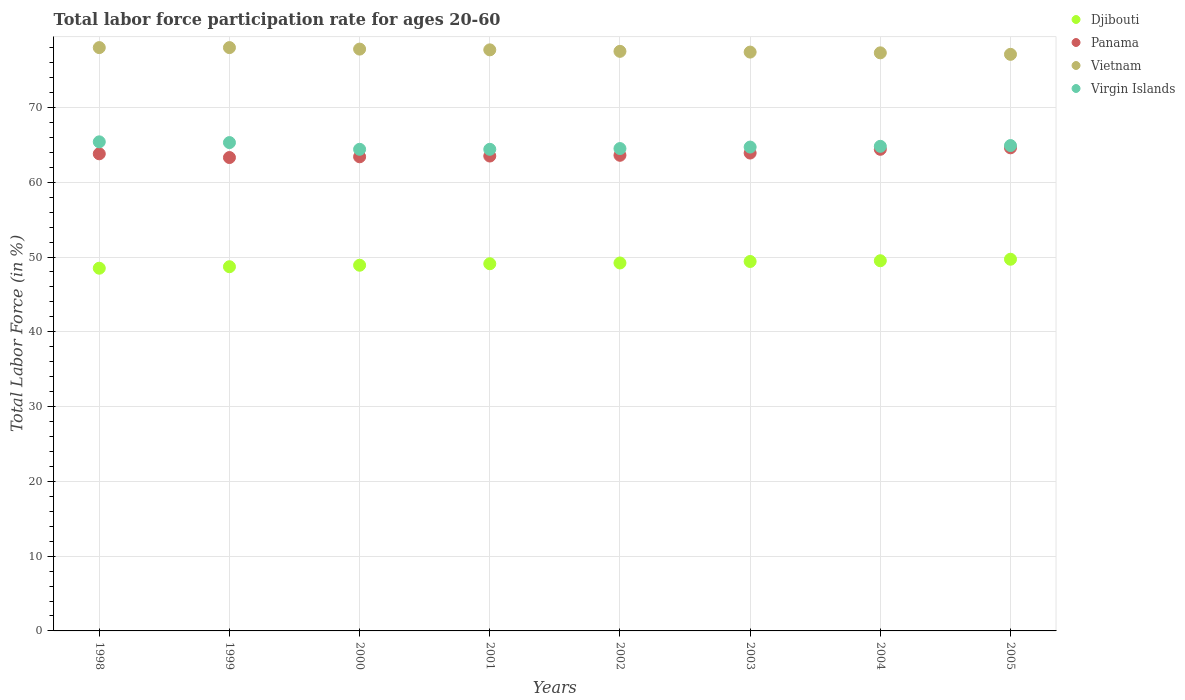Is the number of dotlines equal to the number of legend labels?
Your answer should be compact. Yes. What is the labor force participation rate in Vietnam in 1998?
Keep it short and to the point. 78. Across all years, what is the maximum labor force participation rate in Virgin Islands?
Your answer should be compact. 65.4. Across all years, what is the minimum labor force participation rate in Panama?
Your answer should be compact. 63.3. In which year was the labor force participation rate in Virgin Islands maximum?
Offer a terse response. 1998. In which year was the labor force participation rate in Virgin Islands minimum?
Keep it short and to the point. 2000. What is the total labor force participation rate in Djibouti in the graph?
Ensure brevity in your answer.  393. What is the difference between the labor force participation rate in Panama in 2002 and that in 2005?
Your answer should be compact. -1. What is the difference between the labor force participation rate in Panama in 2002 and the labor force participation rate in Virgin Islands in 2003?
Keep it short and to the point. -1.1. What is the average labor force participation rate in Djibouti per year?
Offer a very short reply. 49.13. In the year 1999, what is the difference between the labor force participation rate in Vietnam and labor force participation rate in Virgin Islands?
Offer a very short reply. 12.7. In how many years, is the labor force participation rate in Virgin Islands greater than 36 %?
Give a very brief answer. 8. What is the ratio of the labor force participation rate in Djibouti in 1998 to that in 2002?
Offer a very short reply. 0.99. Is the labor force participation rate in Virgin Islands in 2001 less than that in 2004?
Keep it short and to the point. Yes. Is the difference between the labor force participation rate in Vietnam in 2001 and 2003 greater than the difference between the labor force participation rate in Virgin Islands in 2001 and 2003?
Keep it short and to the point. Yes. What is the difference between the highest and the second highest labor force participation rate in Panama?
Give a very brief answer. 0.2. What is the difference between the highest and the lowest labor force participation rate in Vietnam?
Your response must be concise. 0.9. In how many years, is the labor force participation rate in Panama greater than the average labor force participation rate in Panama taken over all years?
Ensure brevity in your answer.  3. Is the sum of the labor force participation rate in Virgin Islands in 2001 and 2003 greater than the maximum labor force participation rate in Djibouti across all years?
Make the answer very short. Yes. Is it the case that in every year, the sum of the labor force participation rate in Panama and labor force participation rate in Vietnam  is greater than the sum of labor force participation rate in Virgin Islands and labor force participation rate in Djibouti?
Give a very brief answer. Yes. Does the labor force participation rate in Virgin Islands monotonically increase over the years?
Your response must be concise. No. Does the graph contain any zero values?
Provide a short and direct response. No. Where does the legend appear in the graph?
Your answer should be very brief. Top right. How many legend labels are there?
Provide a succinct answer. 4. What is the title of the graph?
Give a very brief answer. Total labor force participation rate for ages 20-60. What is the label or title of the Y-axis?
Provide a short and direct response. Total Labor Force (in %). What is the Total Labor Force (in %) in Djibouti in 1998?
Ensure brevity in your answer.  48.5. What is the Total Labor Force (in %) in Panama in 1998?
Keep it short and to the point. 63.8. What is the Total Labor Force (in %) in Vietnam in 1998?
Keep it short and to the point. 78. What is the Total Labor Force (in %) in Virgin Islands in 1998?
Provide a succinct answer. 65.4. What is the Total Labor Force (in %) of Djibouti in 1999?
Offer a terse response. 48.7. What is the Total Labor Force (in %) in Panama in 1999?
Keep it short and to the point. 63.3. What is the Total Labor Force (in %) of Vietnam in 1999?
Offer a very short reply. 78. What is the Total Labor Force (in %) in Virgin Islands in 1999?
Your response must be concise. 65.3. What is the Total Labor Force (in %) in Djibouti in 2000?
Keep it short and to the point. 48.9. What is the Total Labor Force (in %) in Panama in 2000?
Make the answer very short. 63.4. What is the Total Labor Force (in %) of Vietnam in 2000?
Provide a succinct answer. 77.8. What is the Total Labor Force (in %) of Virgin Islands in 2000?
Offer a terse response. 64.4. What is the Total Labor Force (in %) in Djibouti in 2001?
Offer a very short reply. 49.1. What is the Total Labor Force (in %) of Panama in 2001?
Offer a terse response. 63.5. What is the Total Labor Force (in %) in Vietnam in 2001?
Your answer should be compact. 77.7. What is the Total Labor Force (in %) in Virgin Islands in 2001?
Offer a terse response. 64.4. What is the Total Labor Force (in %) in Djibouti in 2002?
Ensure brevity in your answer.  49.2. What is the Total Labor Force (in %) in Panama in 2002?
Your response must be concise. 63.6. What is the Total Labor Force (in %) in Vietnam in 2002?
Offer a terse response. 77.5. What is the Total Labor Force (in %) in Virgin Islands in 2002?
Provide a short and direct response. 64.5. What is the Total Labor Force (in %) in Djibouti in 2003?
Provide a succinct answer. 49.4. What is the Total Labor Force (in %) in Panama in 2003?
Your answer should be very brief. 63.9. What is the Total Labor Force (in %) in Vietnam in 2003?
Your answer should be very brief. 77.4. What is the Total Labor Force (in %) of Virgin Islands in 2003?
Your answer should be compact. 64.7. What is the Total Labor Force (in %) of Djibouti in 2004?
Your response must be concise. 49.5. What is the Total Labor Force (in %) of Panama in 2004?
Your answer should be very brief. 64.4. What is the Total Labor Force (in %) in Vietnam in 2004?
Provide a short and direct response. 77.3. What is the Total Labor Force (in %) in Virgin Islands in 2004?
Give a very brief answer. 64.8. What is the Total Labor Force (in %) of Djibouti in 2005?
Offer a very short reply. 49.7. What is the Total Labor Force (in %) in Panama in 2005?
Offer a very short reply. 64.6. What is the Total Labor Force (in %) of Vietnam in 2005?
Make the answer very short. 77.1. What is the Total Labor Force (in %) in Virgin Islands in 2005?
Provide a succinct answer. 64.9. Across all years, what is the maximum Total Labor Force (in %) of Djibouti?
Your answer should be very brief. 49.7. Across all years, what is the maximum Total Labor Force (in %) of Panama?
Offer a very short reply. 64.6. Across all years, what is the maximum Total Labor Force (in %) of Virgin Islands?
Your answer should be compact. 65.4. Across all years, what is the minimum Total Labor Force (in %) in Djibouti?
Your answer should be compact. 48.5. Across all years, what is the minimum Total Labor Force (in %) of Panama?
Your answer should be compact. 63.3. Across all years, what is the minimum Total Labor Force (in %) of Vietnam?
Give a very brief answer. 77.1. Across all years, what is the minimum Total Labor Force (in %) of Virgin Islands?
Your response must be concise. 64.4. What is the total Total Labor Force (in %) in Djibouti in the graph?
Your response must be concise. 393. What is the total Total Labor Force (in %) of Panama in the graph?
Keep it short and to the point. 510.5. What is the total Total Labor Force (in %) in Vietnam in the graph?
Ensure brevity in your answer.  620.8. What is the total Total Labor Force (in %) in Virgin Islands in the graph?
Ensure brevity in your answer.  518.4. What is the difference between the Total Labor Force (in %) of Virgin Islands in 1998 and that in 1999?
Make the answer very short. 0.1. What is the difference between the Total Labor Force (in %) of Panama in 1998 and that in 2000?
Ensure brevity in your answer.  0.4. What is the difference between the Total Labor Force (in %) in Vietnam in 1998 and that in 2000?
Make the answer very short. 0.2. What is the difference between the Total Labor Force (in %) of Virgin Islands in 1998 and that in 2000?
Your response must be concise. 1. What is the difference between the Total Labor Force (in %) in Panama in 1998 and that in 2002?
Offer a very short reply. 0.2. What is the difference between the Total Labor Force (in %) in Vietnam in 1998 and that in 2002?
Offer a terse response. 0.5. What is the difference between the Total Labor Force (in %) in Virgin Islands in 1998 and that in 2002?
Give a very brief answer. 0.9. What is the difference between the Total Labor Force (in %) in Vietnam in 1998 and that in 2003?
Ensure brevity in your answer.  0.6. What is the difference between the Total Labor Force (in %) of Virgin Islands in 1998 and that in 2003?
Offer a terse response. 0.7. What is the difference between the Total Labor Force (in %) of Panama in 1998 and that in 2004?
Your answer should be very brief. -0.6. What is the difference between the Total Labor Force (in %) of Djibouti in 1998 and that in 2005?
Provide a succinct answer. -1.2. What is the difference between the Total Labor Force (in %) in Vietnam in 1998 and that in 2005?
Ensure brevity in your answer.  0.9. What is the difference between the Total Labor Force (in %) of Virgin Islands in 1998 and that in 2005?
Your answer should be compact. 0.5. What is the difference between the Total Labor Force (in %) in Djibouti in 1999 and that in 2000?
Keep it short and to the point. -0.2. What is the difference between the Total Labor Force (in %) in Panama in 1999 and that in 2000?
Your response must be concise. -0.1. What is the difference between the Total Labor Force (in %) in Vietnam in 1999 and that in 2000?
Keep it short and to the point. 0.2. What is the difference between the Total Labor Force (in %) of Djibouti in 1999 and that in 2001?
Provide a succinct answer. -0.4. What is the difference between the Total Labor Force (in %) in Virgin Islands in 1999 and that in 2001?
Your response must be concise. 0.9. What is the difference between the Total Labor Force (in %) in Panama in 1999 and that in 2002?
Keep it short and to the point. -0.3. What is the difference between the Total Labor Force (in %) of Vietnam in 1999 and that in 2002?
Ensure brevity in your answer.  0.5. What is the difference between the Total Labor Force (in %) in Djibouti in 1999 and that in 2003?
Give a very brief answer. -0.7. What is the difference between the Total Labor Force (in %) in Vietnam in 1999 and that in 2004?
Your response must be concise. 0.7. What is the difference between the Total Labor Force (in %) of Virgin Islands in 1999 and that in 2004?
Make the answer very short. 0.5. What is the difference between the Total Labor Force (in %) of Djibouti in 1999 and that in 2005?
Provide a short and direct response. -1. What is the difference between the Total Labor Force (in %) in Panama in 1999 and that in 2005?
Your response must be concise. -1.3. What is the difference between the Total Labor Force (in %) in Panama in 2000 and that in 2001?
Keep it short and to the point. -0.1. What is the difference between the Total Labor Force (in %) of Virgin Islands in 2000 and that in 2001?
Your response must be concise. 0. What is the difference between the Total Labor Force (in %) in Panama in 2000 and that in 2002?
Provide a short and direct response. -0.2. What is the difference between the Total Labor Force (in %) in Djibouti in 2000 and that in 2003?
Provide a short and direct response. -0.5. What is the difference between the Total Labor Force (in %) in Vietnam in 2000 and that in 2003?
Your answer should be very brief. 0.4. What is the difference between the Total Labor Force (in %) in Virgin Islands in 2000 and that in 2003?
Your answer should be very brief. -0.3. What is the difference between the Total Labor Force (in %) in Djibouti in 2000 and that in 2004?
Offer a terse response. -0.6. What is the difference between the Total Labor Force (in %) in Vietnam in 2000 and that in 2004?
Your answer should be very brief. 0.5. What is the difference between the Total Labor Force (in %) in Virgin Islands in 2000 and that in 2004?
Your answer should be very brief. -0.4. What is the difference between the Total Labor Force (in %) of Panama in 2000 and that in 2005?
Your answer should be compact. -1.2. What is the difference between the Total Labor Force (in %) of Vietnam in 2000 and that in 2005?
Give a very brief answer. 0.7. What is the difference between the Total Labor Force (in %) in Virgin Islands in 2000 and that in 2005?
Offer a very short reply. -0.5. What is the difference between the Total Labor Force (in %) in Panama in 2001 and that in 2002?
Make the answer very short. -0.1. What is the difference between the Total Labor Force (in %) of Panama in 2001 and that in 2003?
Keep it short and to the point. -0.4. What is the difference between the Total Labor Force (in %) of Virgin Islands in 2001 and that in 2003?
Provide a succinct answer. -0.3. What is the difference between the Total Labor Force (in %) in Djibouti in 2001 and that in 2004?
Provide a succinct answer. -0.4. What is the difference between the Total Labor Force (in %) in Panama in 2001 and that in 2004?
Keep it short and to the point. -0.9. What is the difference between the Total Labor Force (in %) of Virgin Islands in 2001 and that in 2004?
Your response must be concise. -0.4. What is the difference between the Total Labor Force (in %) in Vietnam in 2001 and that in 2005?
Your answer should be very brief. 0.6. What is the difference between the Total Labor Force (in %) of Virgin Islands in 2001 and that in 2005?
Give a very brief answer. -0.5. What is the difference between the Total Labor Force (in %) in Djibouti in 2002 and that in 2003?
Make the answer very short. -0.2. What is the difference between the Total Labor Force (in %) of Panama in 2002 and that in 2003?
Your answer should be compact. -0.3. What is the difference between the Total Labor Force (in %) in Panama in 2002 and that in 2004?
Your response must be concise. -0.8. What is the difference between the Total Labor Force (in %) of Vietnam in 2002 and that in 2004?
Your answer should be very brief. 0.2. What is the difference between the Total Labor Force (in %) of Panama in 2002 and that in 2005?
Provide a succinct answer. -1. What is the difference between the Total Labor Force (in %) of Vietnam in 2002 and that in 2005?
Ensure brevity in your answer.  0.4. What is the difference between the Total Labor Force (in %) of Djibouti in 2003 and that in 2004?
Your response must be concise. -0.1. What is the difference between the Total Labor Force (in %) in Panama in 2003 and that in 2004?
Your answer should be very brief. -0.5. What is the difference between the Total Labor Force (in %) of Virgin Islands in 2003 and that in 2004?
Your answer should be very brief. -0.1. What is the difference between the Total Labor Force (in %) in Djibouti in 2003 and that in 2005?
Offer a very short reply. -0.3. What is the difference between the Total Labor Force (in %) of Djibouti in 2004 and that in 2005?
Provide a succinct answer. -0.2. What is the difference between the Total Labor Force (in %) in Panama in 2004 and that in 2005?
Offer a very short reply. -0.2. What is the difference between the Total Labor Force (in %) in Virgin Islands in 2004 and that in 2005?
Provide a short and direct response. -0.1. What is the difference between the Total Labor Force (in %) in Djibouti in 1998 and the Total Labor Force (in %) in Panama in 1999?
Your response must be concise. -14.8. What is the difference between the Total Labor Force (in %) in Djibouti in 1998 and the Total Labor Force (in %) in Vietnam in 1999?
Ensure brevity in your answer.  -29.5. What is the difference between the Total Labor Force (in %) in Djibouti in 1998 and the Total Labor Force (in %) in Virgin Islands in 1999?
Offer a terse response. -16.8. What is the difference between the Total Labor Force (in %) of Panama in 1998 and the Total Labor Force (in %) of Vietnam in 1999?
Your answer should be compact. -14.2. What is the difference between the Total Labor Force (in %) in Vietnam in 1998 and the Total Labor Force (in %) in Virgin Islands in 1999?
Make the answer very short. 12.7. What is the difference between the Total Labor Force (in %) in Djibouti in 1998 and the Total Labor Force (in %) in Panama in 2000?
Provide a succinct answer. -14.9. What is the difference between the Total Labor Force (in %) in Djibouti in 1998 and the Total Labor Force (in %) in Vietnam in 2000?
Provide a succinct answer. -29.3. What is the difference between the Total Labor Force (in %) of Djibouti in 1998 and the Total Labor Force (in %) of Virgin Islands in 2000?
Give a very brief answer. -15.9. What is the difference between the Total Labor Force (in %) in Panama in 1998 and the Total Labor Force (in %) in Vietnam in 2000?
Give a very brief answer. -14. What is the difference between the Total Labor Force (in %) in Djibouti in 1998 and the Total Labor Force (in %) in Vietnam in 2001?
Provide a short and direct response. -29.2. What is the difference between the Total Labor Force (in %) of Djibouti in 1998 and the Total Labor Force (in %) of Virgin Islands in 2001?
Your answer should be very brief. -15.9. What is the difference between the Total Labor Force (in %) in Panama in 1998 and the Total Labor Force (in %) in Virgin Islands in 2001?
Give a very brief answer. -0.6. What is the difference between the Total Labor Force (in %) of Djibouti in 1998 and the Total Labor Force (in %) of Panama in 2002?
Ensure brevity in your answer.  -15.1. What is the difference between the Total Labor Force (in %) in Djibouti in 1998 and the Total Labor Force (in %) in Vietnam in 2002?
Ensure brevity in your answer.  -29. What is the difference between the Total Labor Force (in %) of Panama in 1998 and the Total Labor Force (in %) of Vietnam in 2002?
Make the answer very short. -13.7. What is the difference between the Total Labor Force (in %) of Vietnam in 1998 and the Total Labor Force (in %) of Virgin Islands in 2002?
Your answer should be very brief. 13.5. What is the difference between the Total Labor Force (in %) in Djibouti in 1998 and the Total Labor Force (in %) in Panama in 2003?
Your response must be concise. -15.4. What is the difference between the Total Labor Force (in %) of Djibouti in 1998 and the Total Labor Force (in %) of Vietnam in 2003?
Give a very brief answer. -28.9. What is the difference between the Total Labor Force (in %) of Djibouti in 1998 and the Total Labor Force (in %) of Virgin Islands in 2003?
Provide a short and direct response. -16.2. What is the difference between the Total Labor Force (in %) in Panama in 1998 and the Total Labor Force (in %) in Vietnam in 2003?
Your answer should be very brief. -13.6. What is the difference between the Total Labor Force (in %) in Panama in 1998 and the Total Labor Force (in %) in Virgin Islands in 2003?
Ensure brevity in your answer.  -0.9. What is the difference between the Total Labor Force (in %) of Vietnam in 1998 and the Total Labor Force (in %) of Virgin Islands in 2003?
Make the answer very short. 13.3. What is the difference between the Total Labor Force (in %) of Djibouti in 1998 and the Total Labor Force (in %) of Panama in 2004?
Ensure brevity in your answer.  -15.9. What is the difference between the Total Labor Force (in %) in Djibouti in 1998 and the Total Labor Force (in %) in Vietnam in 2004?
Provide a succinct answer. -28.8. What is the difference between the Total Labor Force (in %) of Djibouti in 1998 and the Total Labor Force (in %) of Virgin Islands in 2004?
Offer a very short reply. -16.3. What is the difference between the Total Labor Force (in %) of Panama in 1998 and the Total Labor Force (in %) of Vietnam in 2004?
Ensure brevity in your answer.  -13.5. What is the difference between the Total Labor Force (in %) of Djibouti in 1998 and the Total Labor Force (in %) of Panama in 2005?
Give a very brief answer. -16.1. What is the difference between the Total Labor Force (in %) of Djibouti in 1998 and the Total Labor Force (in %) of Vietnam in 2005?
Give a very brief answer. -28.6. What is the difference between the Total Labor Force (in %) in Djibouti in 1998 and the Total Labor Force (in %) in Virgin Islands in 2005?
Your answer should be very brief. -16.4. What is the difference between the Total Labor Force (in %) in Panama in 1998 and the Total Labor Force (in %) in Vietnam in 2005?
Provide a succinct answer. -13.3. What is the difference between the Total Labor Force (in %) in Vietnam in 1998 and the Total Labor Force (in %) in Virgin Islands in 2005?
Keep it short and to the point. 13.1. What is the difference between the Total Labor Force (in %) of Djibouti in 1999 and the Total Labor Force (in %) of Panama in 2000?
Your answer should be very brief. -14.7. What is the difference between the Total Labor Force (in %) in Djibouti in 1999 and the Total Labor Force (in %) in Vietnam in 2000?
Your answer should be compact. -29.1. What is the difference between the Total Labor Force (in %) of Djibouti in 1999 and the Total Labor Force (in %) of Virgin Islands in 2000?
Offer a very short reply. -15.7. What is the difference between the Total Labor Force (in %) in Panama in 1999 and the Total Labor Force (in %) in Vietnam in 2000?
Give a very brief answer. -14.5. What is the difference between the Total Labor Force (in %) of Vietnam in 1999 and the Total Labor Force (in %) of Virgin Islands in 2000?
Keep it short and to the point. 13.6. What is the difference between the Total Labor Force (in %) of Djibouti in 1999 and the Total Labor Force (in %) of Panama in 2001?
Your response must be concise. -14.8. What is the difference between the Total Labor Force (in %) of Djibouti in 1999 and the Total Labor Force (in %) of Vietnam in 2001?
Provide a succinct answer. -29. What is the difference between the Total Labor Force (in %) in Djibouti in 1999 and the Total Labor Force (in %) in Virgin Islands in 2001?
Provide a succinct answer. -15.7. What is the difference between the Total Labor Force (in %) in Panama in 1999 and the Total Labor Force (in %) in Vietnam in 2001?
Your answer should be compact. -14.4. What is the difference between the Total Labor Force (in %) in Panama in 1999 and the Total Labor Force (in %) in Virgin Islands in 2001?
Offer a terse response. -1.1. What is the difference between the Total Labor Force (in %) of Vietnam in 1999 and the Total Labor Force (in %) of Virgin Islands in 2001?
Provide a short and direct response. 13.6. What is the difference between the Total Labor Force (in %) of Djibouti in 1999 and the Total Labor Force (in %) of Panama in 2002?
Your answer should be very brief. -14.9. What is the difference between the Total Labor Force (in %) in Djibouti in 1999 and the Total Labor Force (in %) in Vietnam in 2002?
Offer a terse response. -28.8. What is the difference between the Total Labor Force (in %) in Djibouti in 1999 and the Total Labor Force (in %) in Virgin Islands in 2002?
Give a very brief answer. -15.8. What is the difference between the Total Labor Force (in %) in Panama in 1999 and the Total Labor Force (in %) in Virgin Islands in 2002?
Ensure brevity in your answer.  -1.2. What is the difference between the Total Labor Force (in %) in Djibouti in 1999 and the Total Labor Force (in %) in Panama in 2003?
Make the answer very short. -15.2. What is the difference between the Total Labor Force (in %) in Djibouti in 1999 and the Total Labor Force (in %) in Vietnam in 2003?
Offer a terse response. -28.7. What is the difference between the Total Labor Force (in %) of Panama in 1999 and the Total Labor Force (in %) of Vietnam in 2003?
Provide a succinct answer. -14.1. What is the difference between the Total Labor Force (in %) of Panama in 1999 and the Total Labor Force (in %) of Virgin Islands in 2003?
Your answer should be compact. -1.4. What is the difference between the Total Labor Force (in %) of Djibouti in 1999 and the Total Labor Force (in %) of Panama in 2004?
Provide a short and direct response. -15.7. What is the difference between the Total Labor Force (in %) of Djibouti in 1999 and the Total Labor Force (in %) of Vietnam in 2004?
Provide a succinct answer. -28.6. What is the difference between the Total Labor Force (in %) in Djibouti in 1999 and the Total Labor Force (in %) in Virgin Islands in 2004?
Keep it short and to the point. -16.1. What is the difference between the Total Labor Force (in %) in Djibouti in 1999 and the Total Labor Force (in %) in Panama in 2005?
Offer a very short reply. -15.9. What is the difference between the Total Labor Force (in %) of Djibouti in 1999 and the Total Labor Force (in %) of Vietnam in 2005?
Ensure brevity in your answer.  -28.4. What is the difference between the Total Labor Force (in %) of Djibouti in 1999 and the Total Labor Force (in %) of Virgin Islands in 2005?
Keep it short and to the point. -16.2. What is the difference between the Total Labor Force (in %) in Panama in 1999 and the Total Labor Force (in %) in Vietnam in 2005?
Give a very brief answer. -13.8. What is the difference between the Total Labor Force (in %) of Djibouti in 2000 and the Total Labor Force (in %) of Panama in 2001?
Make the answer very short. -14.6. What is the difference between the Total Labor Force (in %) in Djibouti in 2000 and the Total Labor Force (in %) in Vietnam in 2001?
Provide a succinct answer. -28.8. What is the difference between the Total Labor Force (in %) in Djibouti in 2000 and the Total Labor Force (in %) in Virgin Islands in 2001?
Offer a very short reply. -15.5. What is the difference between the Total Labor Force (in %) of Panama in 2000 and the Total Labor Force (in %) of Vietnam in 2001?
Provide a short and direct response. -14.3. What is the difference between the Total Labor Force (in %) of Vietnam in 2000 and the Total Labor Force (in %) of Virgin Islands in 2001?
Keep it short and to the point. 13.4. What is the difference between the Total Labor Force (in %) in Djibouti in 2000 and the Total Labor Force (in %) in Panama in 2002?
Ensure brevity in your answer.  -14.7. What is the difference between the Total Labor Force (in %) of Djibouti in 2000 and the Total Labor Force (in %) of Vietnam in 2002?
Your answer should be compact. -28.6. What is the difference between the Total Labor Force (in %) of Djibouti in 2000 and the Total Labor Force (in %) of Virgin Islands in 2002?
Your answer should be very brief. -15.6. What is the difference between the Total Labor Force (in %) of Panama in 2000 and the Total Labor Force (in %) of Vietnam in 2002?
Ensure brevity in your answer.  -14.1. What is the difference between the Total Labor Force (in %) in Panama in 2000 and the Total Labor Force (in %) in Virgin Islands in 2002?
Your answer should be compact. -1.1. What is the difference between the Total Labor Force (in %) of Vietnam in 2000 and the Total Labor Force (in %) of Virgin Islands in 2002?
Make the answer very short. 13.3. What is the difference between the Total Labor Force (in %) in Djibouti in 2000 and the Total Labor Force (in %) in Panama in 2003?
Keep it short and to the point. -15. What is the difference between the Total Labor Force (in %) of Djibouti in 2000 and the Total Labor Force (in %) of Vietnam in 2003?
Offer a terse response. -28.5. What is the difference between the Total Labor Force (in %) of Djibouti in 2000 and the Total Labor Force (in %) of Virgin Islands in 2003?
Provide a succinct answer. -15.8. What is the difference between the Total Labor Force (in %) of Panama in 2000 and the Total Labor Force (in %) of Vietnam in 2003?
Your answer should be very brief. -14. What is the difference between the Total Labor Force (in %) of Vietnam in 2000 and the Total Labor Force (in %) of Virgin Islands in 2003?
Ensure brevity in your answer.  13.1. What is the difference between the Total Labor Force (in %) of Djibouti in 2000 and the Total Labor Force (in %) of Panama in 2004?
Your answer should be very brief. -15.5. What is the difference between the Total Labor Force (in %) in Djibouti in 2000 and the Total Labor Force (in %) in Vietnam in 2004?
Your response must be concise. -28.4. What is the difference between the Total Labor Force (in %) of Djibouti in 2000 and the Total Labor Force (in %) of Virgin Islands in 2004?
Give a very brief answer. -15.9. What is the difference between the Total Labor Force (in %) of Panama in 2000 and the Total Labor Force (in %) of Virgin Islands in 2004?
Offer a terse response. -1.4. What is the difference between the Total Labor Force (in %) of Djibouti in 2000 and the Total Labor Force (in %) of Panama in 2005?
Provide a short and direct response. -15.7. What is the difference between the Total Labor Force (in %) of Djibouti in 2000 and the Total Labor Force (in %) of Vietnam in 2005?
Offer a terse response. -28.2. What is the difference between the Total Labor Force (in %) in Panama in 2000 and the Total Labor Force (in %) in Vietnam in 2005?
Provide a short and direct response. -13.7. What is the difference between the Total Labor Force (in %) of Djibouti in 2001 and the Total Labor Force (in %) of Vietnam in 2002?
Give a very brief answer. -28.4. What is the difference between the Total Labor Force (in %) in Djibouti in 2001 and the Total Labor Force (in %) in Virgin Islands in 2002?
Provide a succinct answer. -15.4. What is the difference between the Total Labor Force (in %) of Panama in 2001 and the Total Labor Force (in %) of Vietnam in 2002?
Provide a short and direct response. -14. What is the difference between the Total Labor Force (in %) of Vietnam in 2001 and the Total Labor Force (in %) of Virgin Islands in 2002?
Your answer should be compact. 13.2. What is the difference between the Total Labor Force (in %) in Djibouti in 2001 and the Total Labor Force (in %) in Panama in 2003?
Provide a short and direct response. -14.8. What is the difference between the Total Labor Force (in %) of Djibouti in 2001 and the Total Labor Force (in %) of Vietnam in 2003?
Keep it short and to the point. -28.3. What is the difference between the Total Labor Force (in %) of Djibouti in 2001 and the Total Labor Force (in %) of Virgin Islands in 2003?
Your answer should be very brief. -15.6. What is the difference between the Total Labor Force (in %) in Djibouti in 2001 and the Total Labor Force (in %) in Panama in 2004?
Make the answer very short. -15.3. What is the difference between the Total Labor Force (in %) of Djibouti in 2001 and the Total Labor Force (in %) of Vietnam in 2004?
Your answer should be compact. -28.2. What is the difference between the Total Labor Force (in %) in Djibouti in 2001 and the Total Labor Force (in %) in Virgin Islands in 2004?
Provide a succinct answer. -15.7. What is the difference between the Total Labor Force (in %) of Vietnam in 2001 and the Total Labor Force (in %) of Virgin Islands in 2004?
Offer a terse response. 12.9. What is the difference between the Total Labor Force (in %) in Djibouti in 2001 and the Total Labor Force (in %) in Panama in 2005?
Provide a succinct answer. -15.5. What is the difference between the Total Labor Force (in %) in Djibouti in 2001 and the Total Labor Force (in %) in Vietnam in 2005?
Provide a short and direct response. -28. What is the difference between the Total Labor Force (in %) of Djibouti in 2001 and the Total Labor Force (in %) of Virgin Islands in 2005?
Your answer should be compact. -15.8. What is the difference between the Total Labor Force (in %) in Panama in 2001 and the Total Labor Force (in %) in Virgin Islands in 2005?
Keep it short and to the point. -1.4. What is the difference between the Total Labor Force (in %) of Djibouti in 2002 and the Total Labor Force (in %) of Panama in 2003?
Offer a very short reply. -14.7. What is the difference between the Total Labor Force (in %) of Djibouti in 2002 and the Total Labor Force (in %) of Vietnam in 2003?
Your response must be concise. -28.2. What is the difference between the Total Labor Force (in %) in Djibouti in 2002 and the Total Labor Force (in %) in Virgin Islands in 2003?
Your answer should be very brief. -15.5. What is the difference between the Total Labor Force (in %) of Panama in 2002 and the Total Labor Force (in %) of Virgin Islands in 2003?
Offer a terse response. -1.1. What is the difference between the Total Labor Force (in %) in Djibouti in 2002 and the Total Labor Force (in %) in Panama in 2004?
Keep it short and to the point. -15.2. What is the difference between the Total Labor Force (in %) in Djibouti in 2002 and the Total Labor Force (in %) in Vietnam in 2004?
Keep it short and to the point. -28.1. What is the difference between the Total Labor Force (in %) in Djibouti in 2002 and the Total Labor Force (in %) in Virgin Islands in 2004?
Keep it short and to the point. -15.6. What is the difference between the Total Labor Force (in %) of Panama in 2002 and the Total Labor Force (in %) of Vietnam in 2004?
Keep it short and to the point. -13.7. What is the difference between the Total Labor Force (in %) of Panama in 2002 and the Total Labor Force (in %) of Virgin Islands in 2004?
Your answer should be compact. -1.2. What is the difference between the Total Labor Force (in %) in Djibouti in 2002 and the Total Labor Force (in %) in Panama in 2005?
Make the answer very short. -15.4. What is the difference between the Total Labor Force (in %) of Djibouti in 2002 and the Total Labor Force (in %) of Vietnam in 2005?
Your response must be concise. -27.9. What is the difference between the Total Labor Force (in %) of Djibouti in 2002 and the Total Labor Force (in %) of Virgin Islands in 2005?
Your answer should be very brief. -15.7. What is the difference between the Total Labor Force (in %) in Panama in 2002 and the Total Labor Force (in %) in Vietnam in 2005?
Offer a very short reply. -13.5. What is the difference between the Total Labor Force (in %) in Panama in 2002 and the Total Labor Force (in %) in Virgin Islands in 2005?
Provide a short and direct response. -1.3. What is the difference between the Total Labor Force (in %) in Vietnam in 2002 and the Total Labor Force (in %) in Virgin Islands in 2005?
Offer a very short reply. 12.6. What is the difference between the Total Labor Force (in %) of Djibouti in 2003 and the Total Labor Force (in %) of Vietnam in 2004?
Keep it short and to the point. -27.9. What is the difference between the Total Labor Force (in %) in Djibouti in 2003 and the Total Labor Force (in %) in Virgin Islands in 2004?
Your answer should be compact. -15.4. What is the difference between the Total Labor Force (in %) of Panama in 2003 and the Total Labor Force (in %) of Virgin Islands in 2004?
Offer a very short reply. -0.9. What is the difference between the Total Labor Force (in %) of Vietnam in 2003 and the Total Labor Force (in %) of Virgin Islands in 2004?
Offer a very short reply. 12.6. What is the difference between the Total Labor Force (in %) of Djibouti in 2003 and the Total Labor Force (in %) of Panama in 2005?
Give a very brief answer. -15.2. What is the difference between the Total Labor Force (in %) of Djibouti in 2003 and the Total Labor Force (in %) of Vietnam in 2005?
Keep it short and to the point. -27.7. What is the difference between the Total Labor Force (in %) in Djibouti in 2003 and the Total Labor Force (in %) in Virgin Islands in 2005?
Your answer should be compact. -15.5. What is the difference between the Total Labor Force (in %) of Panama in 2003 and the Total Labor Force (in %) of Vietnam in 2005?
Your response must be concise. -13.2. What is the difference between the Total Labor Force (in %) of Panama in 2003 and the Total Labor Force (in %) of Virgin Islands in 2005?
Keep it short and to the point. -1. What is the difference between the Total Labor Force (in %) of Vietnam in 2003 and the Total Labor Force (in %) of Virgin Islands in 2005?
Make the answer very short. 12.5. What is the difference between the Total Labor Force (in %) of Djibouti in 2004 and the Total Labor Force (in %) of Panama in 2005?
Ensure brevity in your answer.  -15.1. What is the difference between the Total Labor Force (in %) of Djibouti in 2004 and the Total Labor Force (in %) of Vietnam in 2005?
Ensure brevity in your answer.  -27.6. What is the difference between the Total Labor Force (in %) of Djibouti in 2004 and the Total Labor Force (in %) of Virgin Islands in 2005?
Give a very brief answer. -15.4. What is the difference between the Total Labor Force (in %) in Panama in 2004 and the Total Labor Force (in %) in Vietnam in 2005?
Offer a very short reply. -12.7. What is the average Total Labor Force (in %) in Djibouti per year?
Keep it short and to the point. 49.12. What is the average Total Labor Force (in %) in Panama per year?
Your answer should be compact. 63.81. What is the average Total Labor Force (in %) of Vietnam per year?
Offer a very short reply. 77.6. What is the average Total Labor Force (in %) of Virgin Islands per year?
Keep it short and to the point. 64.8. In the year 1998, what is the difference between the Total Labor Force (in %) in Djibouti and Total Labor Force (in %) in Panama?
Offer a very short reply. -15.3. In the year 1998, what is the difference between the Total Labor Force (in %) of Djibouti and Total Labor Force (in %) of Vietnam?
Provide a short and direct response. -29.5. In the year 1998, what is the difference between the Total Labor Force (in %) of Djibouti and Total Labor Force (in %) of Virgin Islands?
Provide a short and direct response. -16.9. In the year 1999, what is the difference between the Total Labor Force (in %) of Djibouti and Total Labor Force (in %) of Panama?
Make the answer very short. -14.6. In the year 1999, what is the difference between the Total Labor Force (in %) in Djibouti and Total Labor Force (in %) in Vietnam?
Provide a short and direct response. -29.3. In the year 1999, what is the difference between the Total Labor Force (in %) in Djibouti and Total Labor Force (in %) in Virgin Islands?
Provide a short and direct response. -16.6. In the year 1999, what is the difference between the Total Labor Force (in %) in Panama and Total Labor Force (in %) in Vietnam?
Provide a short and direct response. -14.7. In the year 2000, what is the difference between the Total Labor Force (in %) of Djibouti and Total Labor Force (in %) of Vietnam?
Your answer should be very brief. -28.9. In the year 2000, what is the difference between the Total Labor Force (in %) in Djibouti and Total Labor Force (in %) in Virgin Islands?
Give a very brief answer. -15.5. In the year 2000, what is the difference between the Total Labor Force (in %) of Panama and Total Labor Force (in %) of Vietnam?
Offer a terse response. -14.4. In the year 2000, what is the difference between the Total Labor Force (in %) in Panama and Total Labor Force (in %) in Virgin Islands?
Your answer should be compact. -1. In the year 2001, what is the difference between the Total Labor Force (in %) in Djibouti and Total Labor Force (in %) in Panama?
Offer a very short reply. -14.4. In the year 2001, what is the difference between the Total Labor Force (in %) of Djibouti and Total Labor Force (in %) of Vietnam?
Your answer should be very brief. -28.6. In the year 2001, what is the difference between the Total Labor Force (in %) of Djibouti and Total Labor Force (in %) of Virgin Islands?
Keep it short and to the point. -15.3. In the year 2002, what is the difference between the Total Labor Force (in %) in Djibouti and Total Labor Force (in %) in Panama?
Provide a short and direct response. -14.4. In the year 2002, what is the difference between the Total Labor Force (in %) in Djibouti and Total Labor Force (in %) in Vietnam?
Offer a terse response. -28.3. In the year 2002, what is the difference between the Total Labor Force (in %) in Djibouti and Total Labor Force (in %) in Virgin Islands?
Offer a very short reply. -15.3. In the year 2002, what is the difference between the Total Labor Force (in %) in Vietnam and Total Labor Force (in %) in Virgin Islands?
Provide a succinct answer. 13. In the year 2003, what is the difference between the Total Labor Force (in %) of Djibouti and Total Labor Force (in %) of Vietnam?
Ensure brevity in your answer.  -28. In the year 2003, what is the difference between the Total Labor Force (in %) of Djibouti and Total Labor Force (in %) of Virgin Islands?
Provide a succinct answer. -15.3. In the year 2003, what is the difference between the Total Labor Force (in %) of Panama and Total Labor Force (in %) of Vietnam?
Ensure brevity in your answer.  -13.5. In the year 2003, what is the difference between the Total Labor Force (in %) of Vietnam and Total Labor Force (in %) of Virgin Islands?
Ensure brevity in your answer.  12.7. In the year 2004, what is the difference between the Total Labor Force (in %) in Djibouti and Total Labor Force (in %) in Panama?
Keep it short and to the point. -14.9. In the year 2004, what is the difference between the Total Labor Force (in %) of Djibouti and Total Labor Force (in %) of Vietnam?
Give a very brief answer. -27.8. In the year 2004, what is the difference between the Total Labor Force (in %) in Djibouti and Total Labor Force (in %) in Virgin Islands?
Give a very brief answer. -15.3. In the year 2004, what is the difference between the Total Labor Force (in %) of Panama and Total Labor Force (in %) of Vietnam?
Make the answer very short. -12.9. In the year 2004, what is the difference between the Total Labor Force (in %) of Panama and Total Labor Force (in %) of Virgin Islands?
Your answer should be very brief. -0.4. In the year 2005, what is the difference between the Total Labor Force (in %) in Djibouti and Total Labor Force (in %) in Panama?
Your answer should be very brief. -14.9. In the year 2005, what is the difference between the Total Labor Force (in %) of Djibouti and Total Labor Force (in %) of Vietnam?
Your answer should be very brief. -27.4. In the year 2005, what is the difference between the Total Labor Force (in %) in Djibouti and Total Labor Force (in %) in Virgin Islands?
Provide a succinct answer. -15.2. In the year 2005, what is the difference between the Total Labor Force (in %) in Vietnam and Total Labor Force (in %) in Virgin Islands?
Your answer should be very brief. 12.2. What is the ratio of the Total Labor Force (in %) in Djibouti in 1998 to that in 1999?
Make the answer very short. 1. What is the ratio of the Total Labor Force (in %) in Panama in 1998 to that in 1999?
Make the answer very short. 1.01. What is the ratio of the Total Labor Force (in %) in Vietnam in 1998 to that in 1999?
Provide a succinct answer. 1. What is the ratio of the Total Labor Force (in %) in Vietnam in 1998 to that in 2000?
Provide a succinct answer. 1. What is the ratio of the Total Labor Force (in %) in Virgin Islands in 1998 to that in 2000?
Offer a terse response. 1.02. What is the ratio of the Total Labor Force (in %) in Virgin Islands in 1998 to that in 2001?
Make the answer very short. 1.02. What is the ratio of the Total Labor Force (in %) in Djibouti in 1998 to that in 2002?
Give a very brief answer. 0.99. What is the ratio of the Total Labor Force (in %) of Vietnam in 1998 to that in 2002?
Make the answer very short. 1.01. What is the ratio of the Total Labor Force (in %) in Djibouti in 1998 to that in 2003?
Provide a succinct answer. 0.98. What is the ratio of the Total Labor Force (in %) of Vietnam in 1998 to that in 2003?
Give a very brief answer. 1.01. What is the ratio of the Total Labor Force (in %) of Virgin Islands in 1998 to that in 2003?
Give a very brief answer. 1.01. What is the ratio of the Total Labor Force (in %) in Djibouti in 1998 to that in 2004?
Provide a succinct answer. 0.98. What is the ratio of the Total Labor Force (in %) in Vietnam in 1998 to that in 2004?
Keep it short and to the point. 1.01. What is the ratio of the Total Labor Force (in %) of Virgin Islands in 1998 to that in 2004?
Keep it short and to the point. 1.01. What is the ratio of the Total Labor Force (in %) of Djibouti in 1998 to that in 2005?
Ensure brevity in your answer.  0.98. What is the ratio of the Total Labor Force (in %) of Panama in 1998 to that in 2005?
Keep it short and to the point. 0.99. What is the ratio of the Total Labor Force (in %) of Vietnam in 1998 to that in 2005?
Give a very brief answer. 1.01. What is the ratio of the Total Labor Force (in %) of Virgin Islands in 1998 to that in 2005?
Your answer should be compact. 1.01. What is the ratio of the Total Labor Force (in %) in Djibouti in 1999 to that in 2000?
Provide a short and direct response. 1. What is the ratio of the Total Labor Force (in %) in Panama in 1999 to that in 2000?
Provide a succinct answer. 1. What is the ratio of the Total Labor Force (in %) in Vietnam in 1999 to that in 2000?
Offer a terse response. 1. What is the ratio of the Total Labor Force (in %) of Panama in 1999 to that in 2001?
Your response must be concise. 1. What is the ratio of the Total Labor Force (in %) of Vietnam in 1999 to that in 2001?
Make the answer very short. 1. What is the ratio of the Total Labor Force (in %) of Panama in 1999 to that in 2002?
Provide a short and direct response. 1. What is the ratio of the Total Labor Force (in %) in Virgin Islands in 1999 to that in 2002?
Your answer should be compact. 1.01. What is the ratio of the Total Labor Force (in %) of Djibouti in 1999 to that in 2003?
Provide a succinct answer. 0.99. What is the ratio of the Total Labor Force (in %) of Panama in 1999 to that in 2003?
Your response must be concise. 0.99. What is the ratio of the Total Labor Force (in %) in Vietnam in 1999 to that in 2003?
Your answer should be compact. 1.01. What is the ratio of the Total Labor Force (in %) in Virgin Islands in 1999 to that in 2003?
Provide a short and direct response. 1.01. What is the ratio of the Total Labor Force (in %) in Djibouti in 1999 to that in 2004?
Offer a terse response. 0.98. What is the ratio of the Total Labor Force (in %) of Panama in 1999 to that in 2004?
Provide a succinct answer. 0.98. What is the ratio of the Total Labor Force (in %) of Vietnam in 1999 to that in 2004?
Your answer should be compact. 1.01. What is the ratio of the Total Labor Force (in %) of Virgin Islands in 1999 to that in 2004?
Your answer should be very brief. 1.01. What is the ratio of the Total Labor Force (in %) in Djibouti in 1999 to that in 2005?
Ensure brevity in your answer.  0.98. What is the ratio of the Total Labor Force (in %) in Panama in 1999 to that in 2005?
Ensure brevity in your answer.  0.98. What is the ratio of the Total Labor Force (in %) of Vietnam in 1999 to that in 2005?
Offer a very short reply. 1.01. What is the ratio of the Total Labor Force (in %) of Virgin Islands in 1999 to that in 2005?
Give a very brief answer. 1.01. What is the ratio of the Total Labor Force (in %) of Djibouti in 2000 to that in 2001?
Provide a short and direct response. 1. What is the ratio of the Total Labor Force (in %) in Vietnam in 2000 to that in 2001?
Make the answer very short. 1. What is the ratio of the Total Labor Force (in %) of Virgin Islands in 2000 to that in 2001?
Keep it short and to the point. 1. What is the ratio of the Total Labor Force (in %) of Panama in 2000 to that in 2002?
Provide a succinct answer. 1. What is the ratio of the Total Labor Force (in %) in Vietnam in 2000 to that in 2002?
Your answer should be compact. 1. What is the ratio of the Total Labor Force (in %) in Virgin Islands in 2000 to that in 2002?
Your answer should be very brief. 1. What is the ratio of the Total Labor Force (in %) of Djibouti in 2000 to that in 2004?
Give a very brief answer. 0.99. What is the ratio of the Total Labor Force (in %) in Panama in 2000 to that in 2004?
Provide a short and direct response. 0.98. What is the ratio of the Total Labor Force (in %) of Vietnam in 2000 to that in 2004?
Your answer should be compact. 1.01. What is the ratio of the Total Labor Force (in %) in Virgin Islands in 2000 to that in 2004?
Make the answer very short. 0.99. What is the ratio of the Total Labor Force (in %) of Djibouti in 2000 to that in 2005?
Provide a succinct answer. 0.98. What is the ratio of the Total Labor Force (in %) of Panama in 2000 to that in 2005?
Provide a succinct answer. 0.98. What is the ratio of the Total Labor Force (in %) in Vietnam in 2000 to that in 2005?
Make the answer very short. 1.01. What is the ratio of the Total Labor Force (in %) in Panama in 2001 to that in 2002?
Give a very brief answer. 1. What is the ratio of the Total Labor Force (in %) of Vietnam in 2001 to that in 2002?
Provide a short and direct response. 1. What is the ratio of the Total Labor Force (in %) in Djibouti in 2001 to that in 2003?
Your response must be concise. 0.99. What is the ratio of the Total Labor Force (in %) in Virgin Islands in 2001 to that in 2003?
Your answer should be very brief. 1. What is the ratio of the Total Labor Force (in %) of Djibouti in 2001 to that in 2004?
Your answer should be compact. 0.99. What is the ratio of the Total Labor Force (in %) in Panama in 2001 to that in 2004?
Your response must be concise. 0.99. What is the ratio of the Total Labor Force (in %) of Djibouti in 2001 to that in 2005?
Provide a short and direct response. 0.99. What is the ratio of the Total Labor Force (in %) in Virgin Islands in 2001 to that in 2005?
Offer a terse response. 0.99. What is the ratio of the Total Labor Force (in %) in Panama in 2002 to that in 2003?
Provide a short and direct response. 1. What is the ratio of the Total Labor Force (in %) in Vietnam in 2002 to that in 2003?
Give a very brief answer. 1. What is the ratio of the Total Labor Force (in %) in Panama in 2002 to that in 2004?
Your answer should be very brief. 0.99. What is the ratio of the Total Labor Force (in %) in Djibouti in 2002 to that in 2005?
Give a very brief answer. 0.99. What is the ratio of the Total Labor Force (in %) in Panama in 2002 to that in 2005?
Your response must be concise. 0.98. What is the ratio of the Total Labor Force (in %) of Vietnam in 2002 to that in 2005?
Keep it short and to the point. 1.01. What is the ratio of the Total Labor Force (in %) in Panama in 2003 to that in 2004?
Offer a terse response. 0.99. What is the ratio of the Total Labor Force (in %) of Vietnam in 2003 to that in 2004?
Offer a very short reply. 1. What is the ratio of the Total Labor Force (in %) of Virgin Islands in 2003 to that in 2004?
Make the answer very short. 1. What is the ratio of the Total Labor Force (in %) of Djibouti in 2004 to that in 2005?
Your answer should be very brief. 1. What is the ratio of the Total Labor Force (in %) in Vietnam in 2004 to that in 2005?
Offer a terse response. 1. What is the difference between the highest and the lowest Total Labor Force (in %) in Djibouti?
Give a very brief answer. 1.2. What is the difference between the highest and the lowest Total Labor Force (in %) of Panama?
Provide a succinct answer. 1.3. What is the difference between the highest and the lowest Total Labor Force (in %) in Vietnam?
Keep it short and to the point. 0.9. 